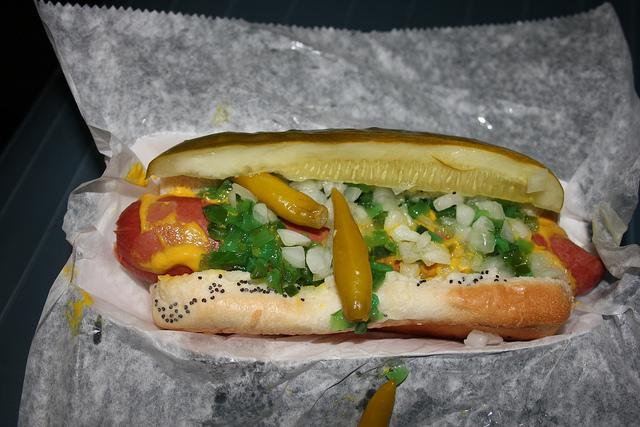Does this hot dog have hot peppers on it?
Be succinct. Yes. What kind of bun is this?
Concise answer only. Hot dog. Is this a Chicago style hot dog?
Be succinct. Yes. 